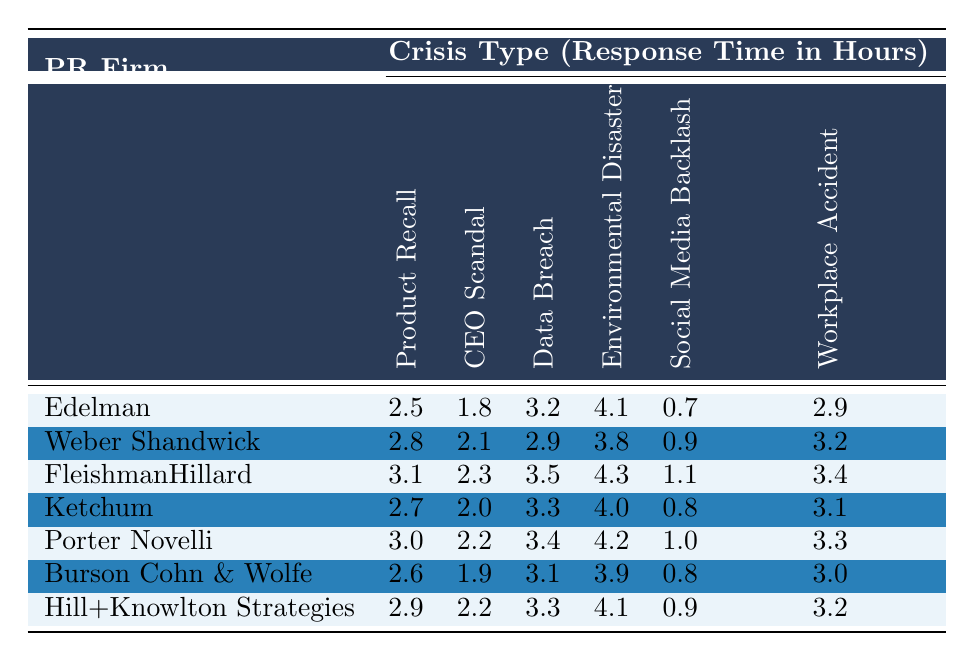What is the fastest response time for a CEO Scandal among the PR firms? Looking at the response times for "CEO Scandal" across all firms, the lowest value is 1.8 hours from Edelman.
Answer: 1.8 hours Which PR firm takes the longest time to respond to an Environmental Disaster? The response times for "Environmental Disaster" are compared: FleishmanHillard takes 4.3 hours, which is longer than all other firms.
Answer: FleishmanHillard Calculate the average response time for Product Recall across all firms. Adding the response times for "Product Recall" (2.5 + 2.8 + 3.1 + 2.7 + 3.0 + 2.6 + 2.9) gives 19.6 hours, and dividing by 7 firms gives an average of approximately 2.8 hours.
Answer: 2.8 hours Is it true that Burson Cohn & Wolfe has a faster response time for Social Media Backlash than Ketchum? Burson Cohn & Wolfe has a response time of 0.8 hours, whereas Ketchum has 0.8 as well, so they are equal. Therefore, the statement is false.
Answer: No Find the difference in response times for Data Breach between FleishmanHillard and Edelman. FleishmanHillard has a response time of 3.5 hours while Edelman has 3.2 hours. The difference is 3.5 - 3.2 = 0.3 hours.
Answer: 0.3 hours Which firm has the most consistent response times across all crisis types? To determine consistency, we analyze the response times for all firms. Burson Cohn & Wolfe has a lower range between its fastest (1.9 hours) and slowest (3.9 hours) responses compared to other firms.
Answer: Burson Cohn & Wolfe Calculate the median response time for Workplace Accidents across the firms. Listing the response times for "Workplace Accident": 2.9, 3.2, 3.4, 3.1, 3.3, 3.0, 3.2. Sorting them gives: 2.9, 3.0, 3.1, 3.2, 3.2, 3.3, 3.4. The median is the fourth value, which is 3.2 hours.
Answer: 3.2 hours Which crisis type does Porter Novelli respond to the quickest? Reviewing Porter Novelli's response times, the quickest is for Social Media Backlash, which is 1.0 hours.
Answer: Social Media Backlash Is there a PR firm that has the same response time for at least two crisis types? Analyzing the data reveals that both Burson Cohn & Wolfe and Ketchum have a response time of 3.3 hours for Data Breach.
Answer: Yes 